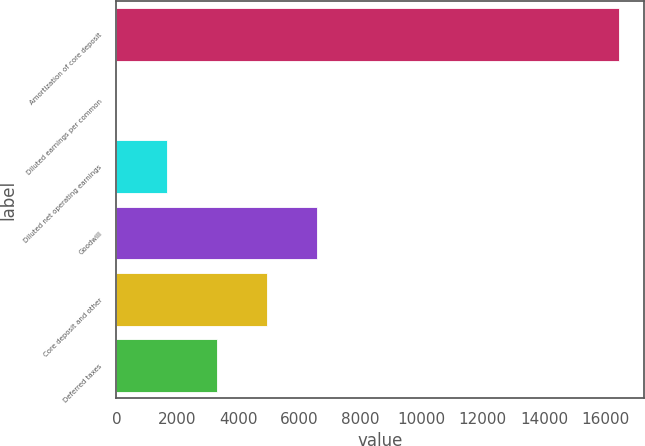Convert chart. <chart><loc_0><loc_0><loc_500><loc_500><bar_chart><fcel>Amortization of core deposit<fcel>Diluted earnings per common<fcel>Diluted net operating earnings<fcel>Goodwill<fcel>Core deposit and other<fcel>Deferred taxes<nl><fcel>16457<fcel>1.95<fcel>1647.46<fcel>6583.98<fcel>4938.48<fcel>3292.97<nl></chart> 